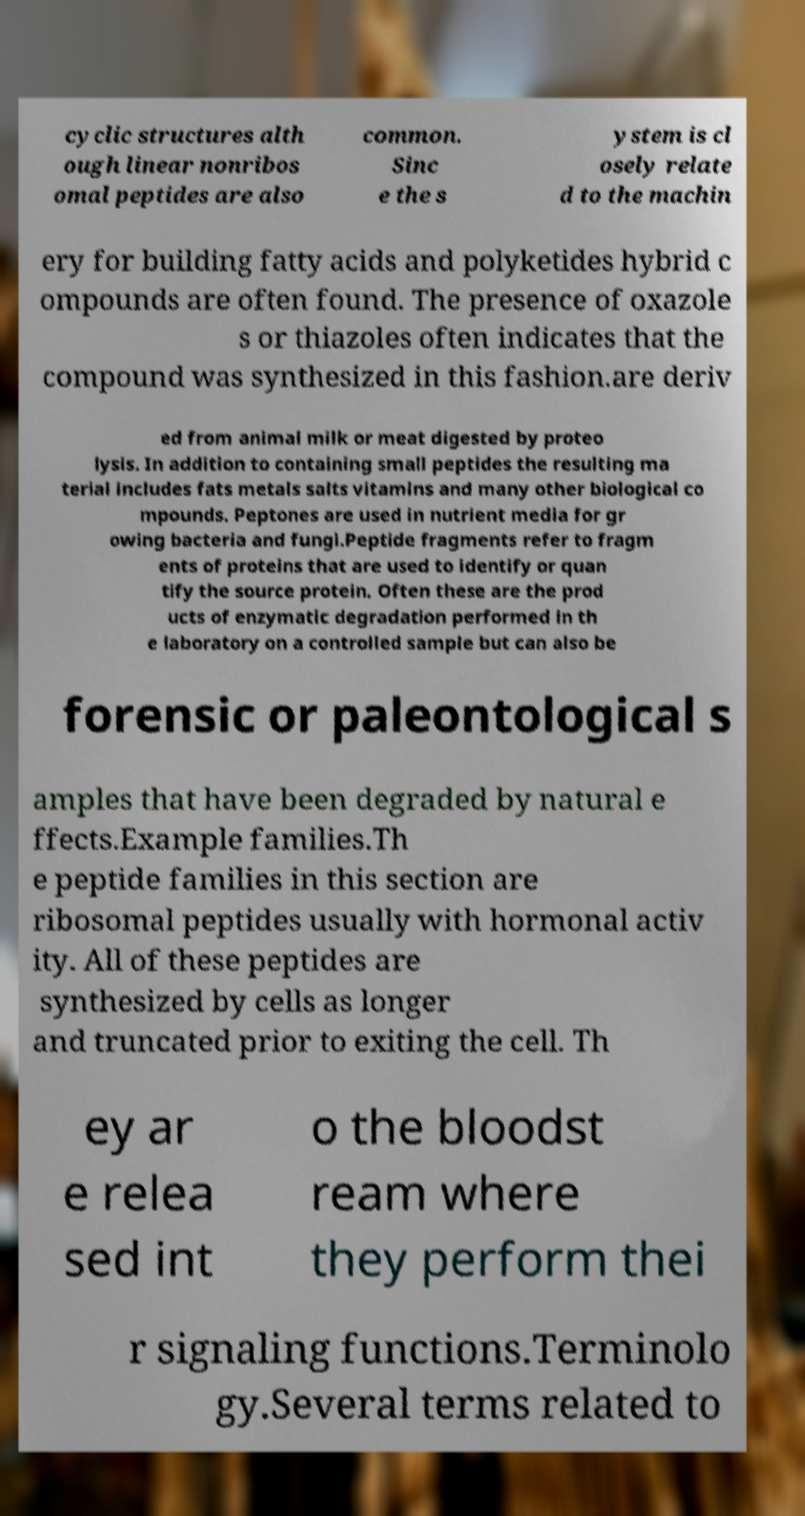Please identify and transcribe the text found in this image. cyclic structures alth ough linear nonribos omal peptides are also common. Sinc e the s ystem is cl osely relate d to the machin ery for building fatty acids and polyketides hybrid c ompounds are often found. The presence of oxazole s or thiazoles often indicates that the compound was synthesized in this fashion.are deriv ed from animal milk or meat digested by proteo lysis. In addition to containing small peptides the resulting ma terial includes fats metals salts vitamins and many other biological co mpounds. Peptones are used in nutrient media for gr owing bacteria and fungi.Peptide fragments refer to fragm ents of proteins that are used to identify or quan tify the source protein. Often these are the prod ucts of enzymatic degradation performed in th e laboratory on a controlled sample but can also be forensic or paleontological s amples that have been degraded by natural e ffects.Example families.Th e peptide families in this section are ribosomal peptides usually with hormonal activ ity. All of these peptides are synthesized by cells as longer and truncated prior to exiting the cell. Th ey ar e relea sed int o the bloodst ream where they perform thei r signaling functions.Terminolo gy.Several terms related to 